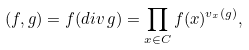Convert formula to latex. <formula><loc_0><loc_0><loc_500><loc_500>( f , g ) = f ( d i v \, g ) = \prod _ { x \in C } f ( x ) ^ { v _ { x } ( g ) } ,</formula> 